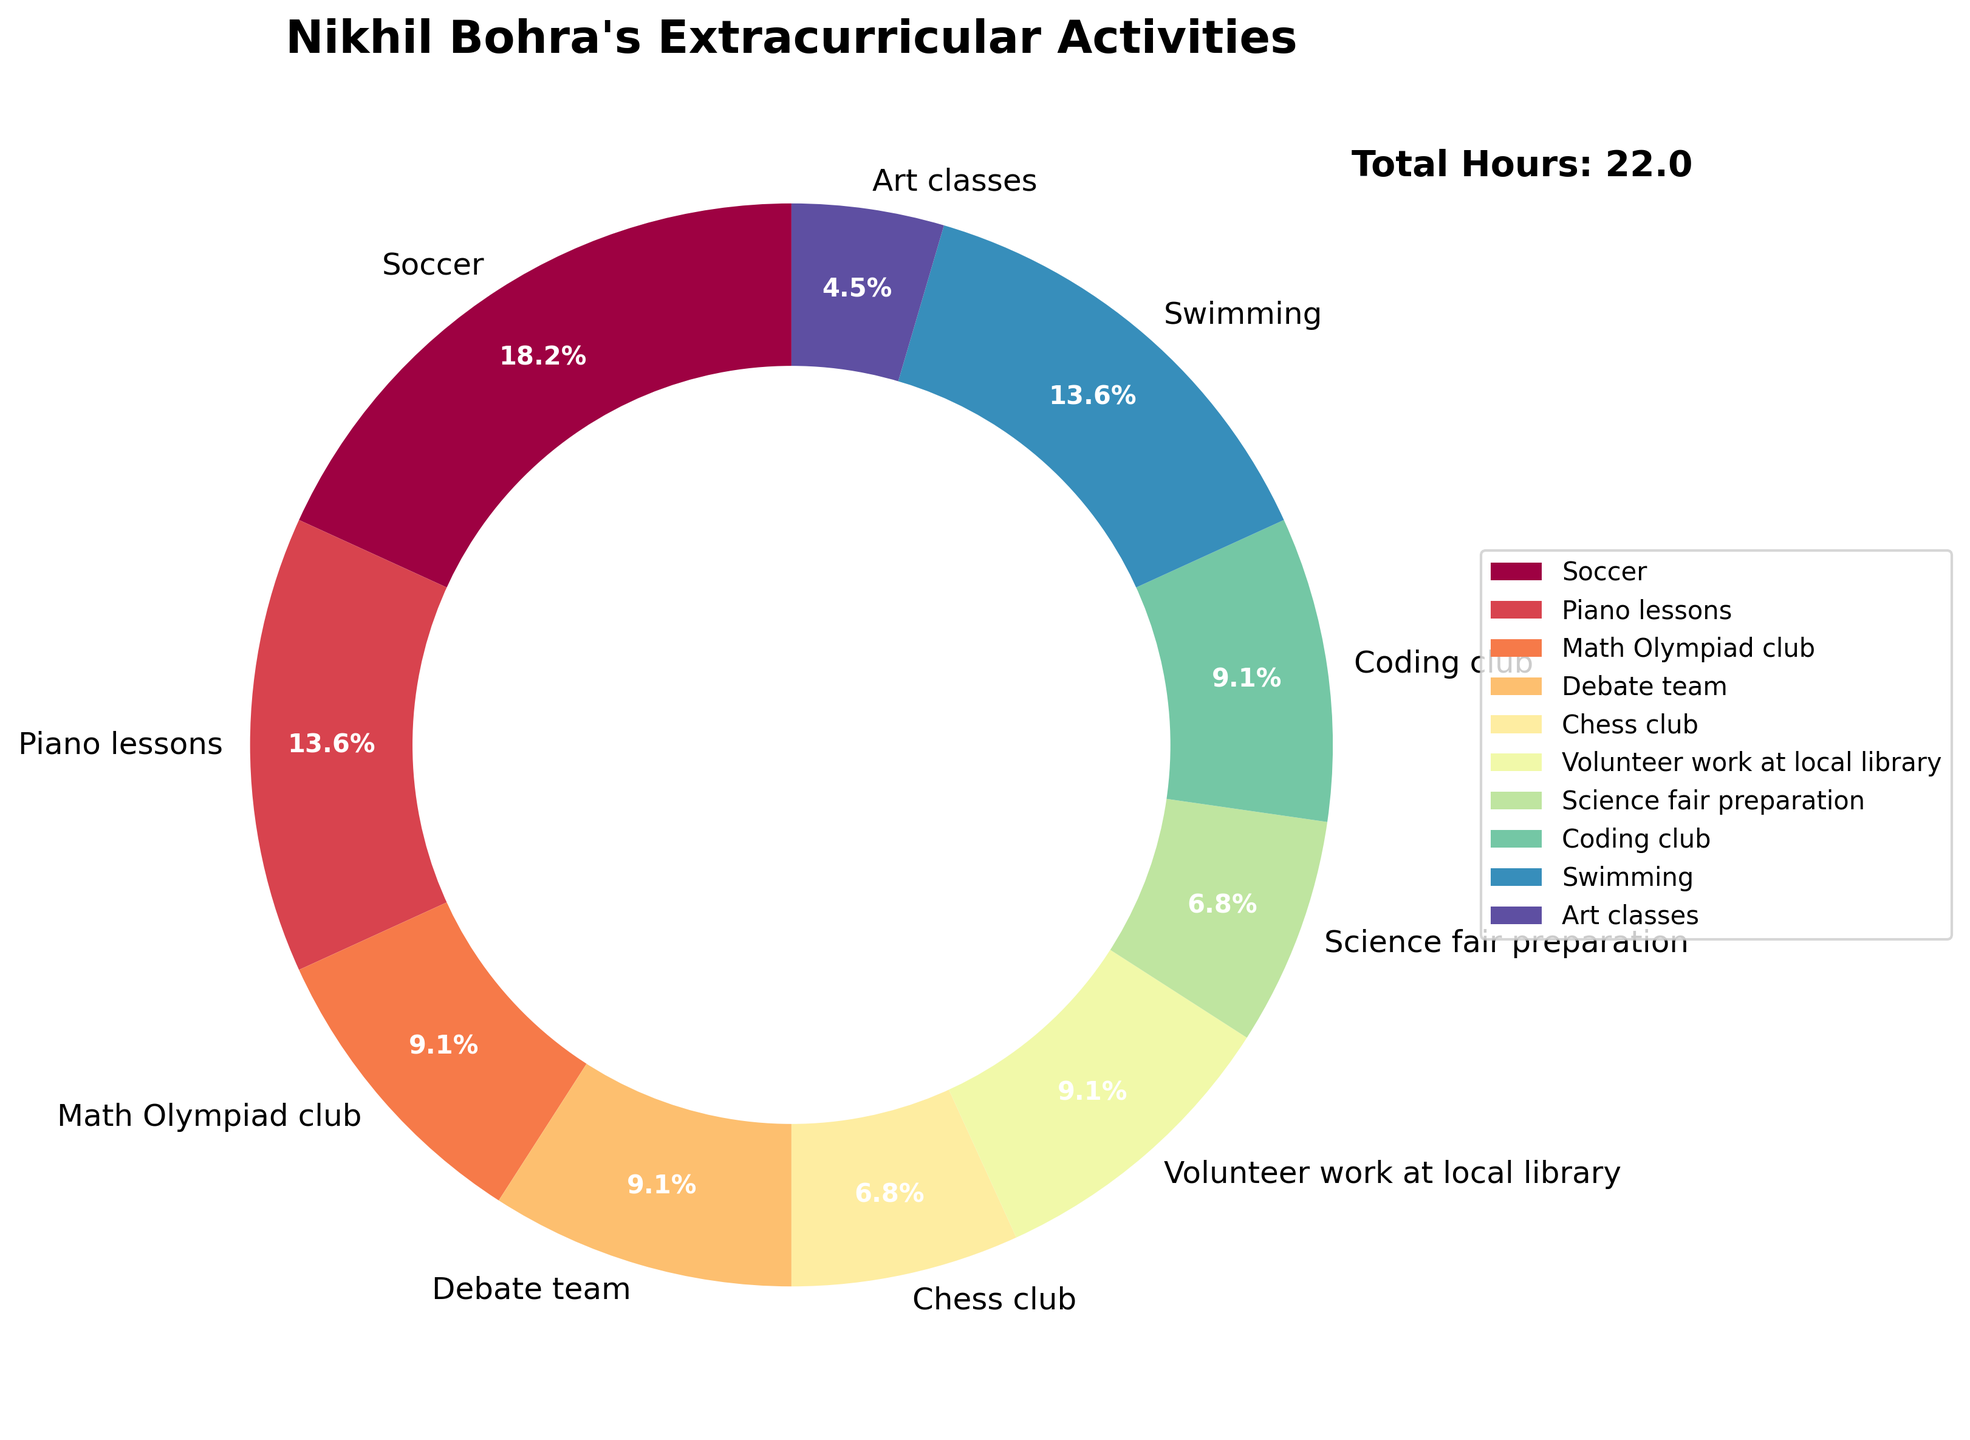What's the total time Nikhil spends on academic clubs? To calculate the total time spent on academic clubs, add the hours from Math Olympiad club, Debate team, Chess club, and Coding club. This is 2 + 2 + 1.5 + 2 = 7.5 hours.
Answer: 7.5 hours Which activity does Nikhil spend the most time on, and how much time is it? The activity Nikhil spends the most time on is the one with the largest percentage in the pie chart. According to the chart, Soccer has the largest slice, representing 4 hours per week.
Answer: Soccer, 4 hours How many hours in total does Nikhil spend on sports activities? To find the total time spent on sports, add the hours from Soccer and Swimming. This is 4 + 3 = 7 hours.
Answer: 7 hours What percentage of Nikhil's time is spent on music-related activities? The music-related activity is Piano lessons, which takes up 3 hours. Calculate the percentage by (3 / total hours) * 100. The total hours spent on all activities is 22.  Therefore, (3 / 22) * 100 ≈ 13.6%.
Answer: 13.6% Which takes more of Nikhil's time: Debate team or Art classes? Compare the time spent on Debate team (2 hours) and Art classes (1 hour). Nikhil spends more time on Debate team.
Answer: Debate team Is the time spent on Science fair preparation equal to the time spent on Chess club? Check the hours for both activities. Science fair preparation takes 1.5 hours, and Chess club also takes 1.5 hours, so they are equal.
Answer: Yes How does the time spent on Volunteer work at local library compare to the time spent on Coding club? Compare the hours: Volunteer work at local library is 2 hours, and Coding club is 2 hours; both are equal.
Answer: Equal Combining three activities, how much time does Nikhil spend on Swimming, Piano lessons, and Art classes? Add the hours for Swimming (3), Piano lessons (3), and Art classes (1): 3 + 3 + 1 = 7 hours.
Answer: 7 hours Name an activity that has less time spent compared to Chess club but more time than Art classes. Chess club is 1.5 hours and Art classes is 1 hour. An activity spending more than 1 hour but less than 1.5 hours is not available, so there is no such activity.
Answer: None 